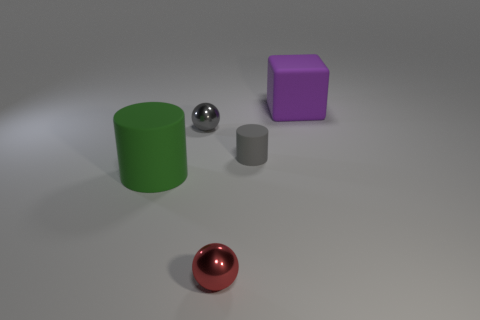There is a metallic thing that is behind the red thing; does it have the same shape as the shiny thing in front of the small gray cylinder?
Keep it short and to the point. Yes. What material is the green thing?
Keep it short and to the point. Rubber. Do the tiny red object in front of the large rubber cylinder and the gray ball have the same material?
Provide a succinct answer. Yes. Is the number of gray metallic spheres in front of the small gray metallic object less than the number of tiny yellow cylinders?
Keep it short and to the point. No. What is the color of the rubber object that is the same size as the purple cube?
Provide a succinct answer. Green. How many other purple objects are the same shape as the purple matte object?
Ensure brevity in your answer.  0. There is a cylinder that is in front of the small cylinder; what color is it?
Ensure brevity in your answer.  Green. How many metallic objects are purple objects or tiny red spheres?
Offer a terse response. 1. There is a shiny object that is the same color as the small cylinder; what is its shape?
Ensure brevity in your answer.  Sphere. How many cylinders are the same size as the purple thing?
Offer a very short reply. 1. 